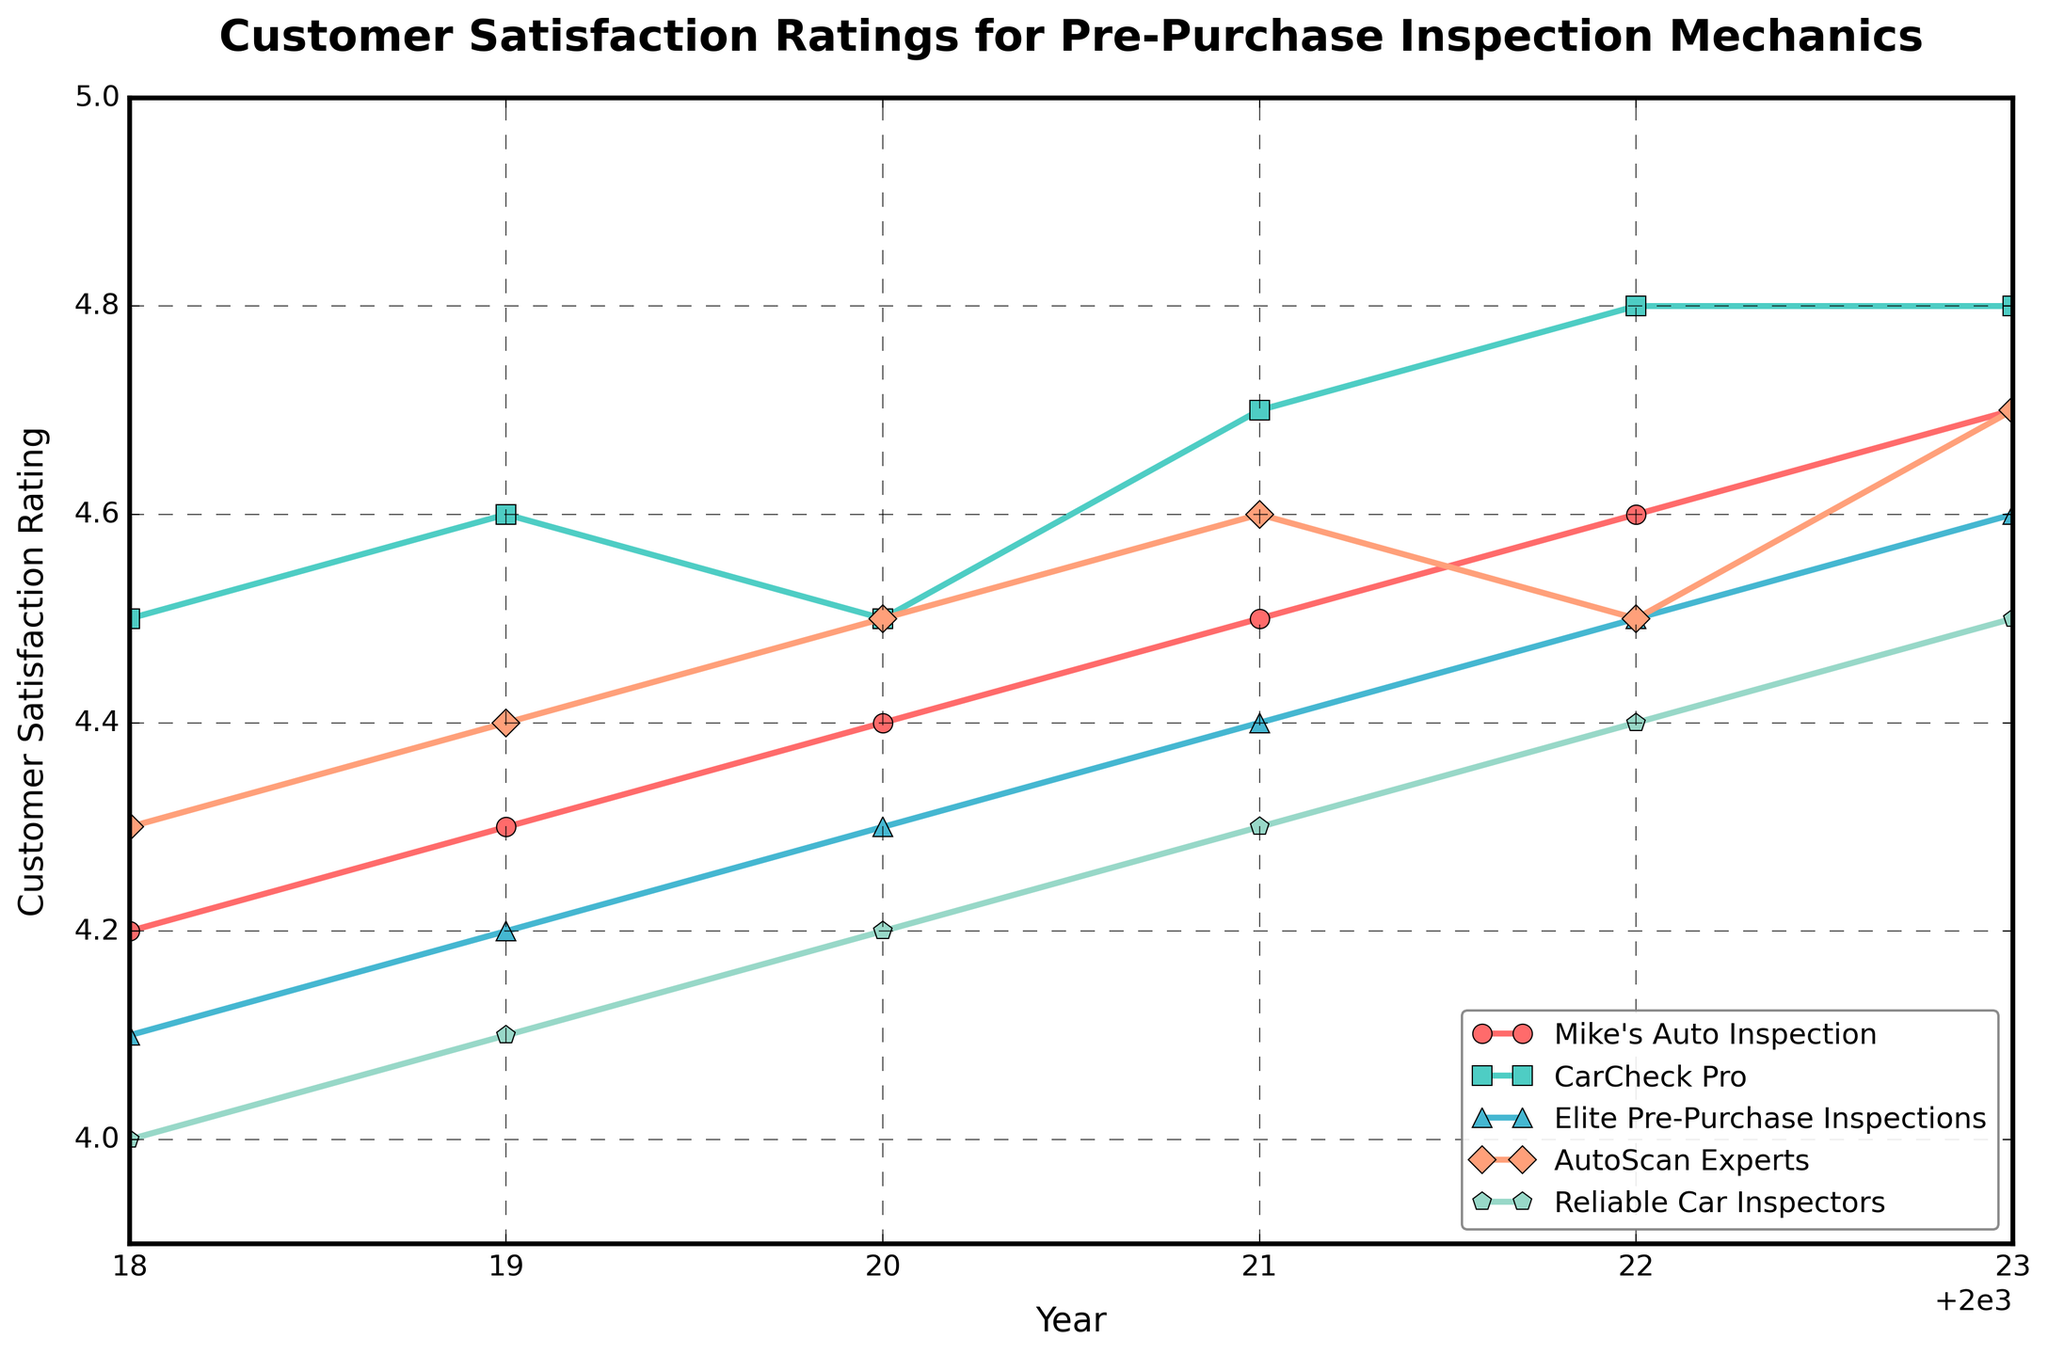What is the customer satisfaction rating trend for "AutoScan Experts" from 2018 to 2023? Observe the plotted points for "AutoScan Experts" over the years. Starting from 4.3 in 2018, the ratings gradually increase each year, peaking at 4.7 in 2023.
Answer: Increasing Which mechanic had the highest customer satisfaction rating in 2023? Check the plotted points at the year 2023 for each mechanic. "CarCheck Pro" and "Elite Pre-Purchase Inspections" both have the highest rating of 4.8.
Answer: CarCheck Pro and Elite Pre-Purchase Inspections How much did "Mike's Auto Inspection" satisfaction rating increase from 2018 to 2023? Find the ratings in 2018 (4.2) and 2023 (4.7), then calculate the difference: 4.7 - 4.2.
Answer: 0.5 Which mechanic showed the most consistent (smallest change) rating from 2018 to 2023? Calculate the difference between the highest and lowest ratings for each mechanic over the years. "CarCheck Pro" varies from 4.5 to 4.8, "Reliable Car Inspectors" varies from 4.0 to 4.5, and so on. The smallest range is 0.3 for "CarCheck Pro."
Answer: CarCheck Pro In which year did "Reliable Car Inspectors" surpass a satisfaction rating of 4.0? Look at the ratings for "Reliable Car Inspectors" over the years. The rating surpasses 4.0 in 2019 (4.1).
Answer: 2019 Which mechanic had the most improvement in customer satisfaction from 2018 to 2023? Calculate the difference in ratings from 2018 to 2023 for each mechanic. "Mike's Auto Inspection" improved by 0.5, "CarCheck Pro" improved by 0.3, "Elite Pre-Purchase Inspections" by 0.5, "AutoScan Experts" by 0.4, and "Reliable Car Inspectors" by 0.5. However, "AutoScan Experts" improved by 0.4 only. "Mike's Auto Inspection," "Elite Pre-Purchase Inspections," and "Reliable Car Inspectors" have the highest improvement of 0.5.
Answer: Mike's Auto Inspection, Elite Pre-Purchase Inspections, Reliable Car Inspectors Which two mechanics had equal customer satisfaction ratings in 2020? Look at the ratings for each mechanic in 2020. "CarCheck Pro" and "AutoScan Experts" both have a rating of 4.5.
Answer: CarCheck Pro and AutoScan Experts From 2020 to 2023, which mechanic’s rating remained the same for one year? Track the ratings yearly; for "AutoScan Experts," the rating is 4.5 in 2020 and 2022, indicating no change in one of those years.
Answer: AutoScan Experts 